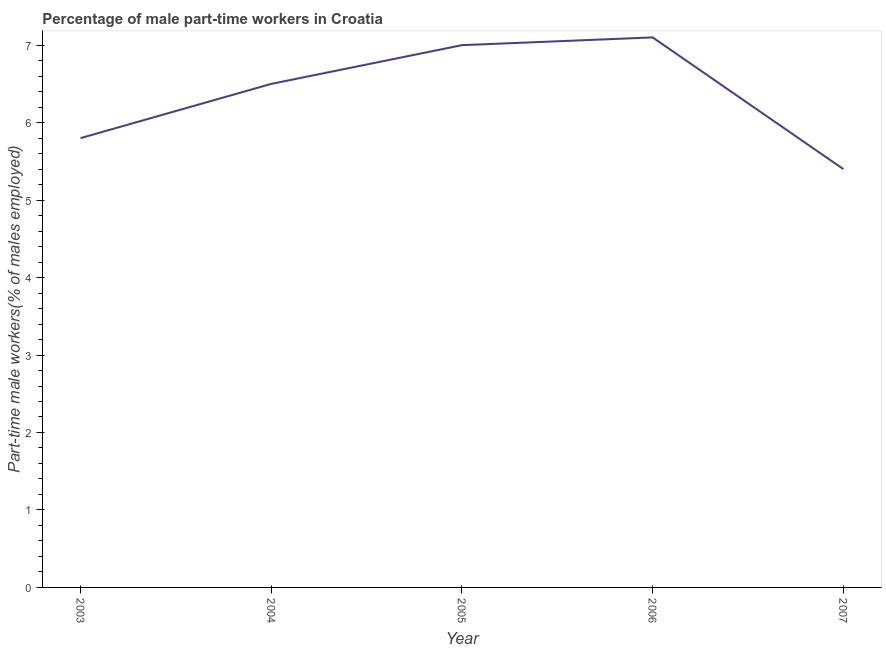What is the percentage of part-time male workers in 2003?
Your response must be concise. 5.8. Across all years, what is the maximum percentage of part-time male workers?
Keep it short and to the point. 7.1. Across all years, what is the minimum percentage of part-time male workers?
Your answer should be very brief. 5.4. In which year was the percentage of part-time male workers maximum?
Provide a short and direct response. 2006. In which year was the percentage of part-time male workers minimum?
Provide a succinct answer. 2007. What is the sum of the percentage of part-time male workers?
Offer a terse response. 31.8. What is the average percentage of part-time male workers per year?
Your response must be concise. 6.36. What is the ratio of the percentage of part-time male workers in 2005 to that in 2007?
Provide a short and direct response. 1.3. Is the percentage of part-time male workers in 2003 less than that in 2004?
Offer a terse response. Yes. Is the difference between the percentage of part-time male workers in 2006 and 2007 greater than the difference between any two years?
Your response must be concise. Yes. What is the difference between the highest and the second highest percentage of part-time male workers?
Make the answer very short. 0.1. Is the sum of the percentage of part-time male workers in 2006 and 2007 greater than the maximum percentage of part-time male workers across all years?
Give a very brief answer. Yes. What is the difference between the highest and the lowest percentage of part-time male workers?
Your response must be concise. 1.7. Does the percentage of part-time male workers monotonically increase over the years?
Ensure brevity in your answer.  No. How many lines are there?
Make the answer very short. 1. How many years are there in the graph?
Your answer should be very brief. 5. Are the values on the major ticks of Y-axis written in scientific E-notation?
Ensure brevity in your answer.  No. Does the graph contain grids?
Offer a terse response. No. What is the title of the graph?
Your answer should be very brief. Percentage of male part-time workers in Croatia. What is the label or title of the X-axis?
Your answer should be compact. Year. What is the label or title of the Y-axis?
Your response must be concise. Part-time male workers(% of males employed). What is the Part-time male workers(% of males employed) of 2003?
Keep it short and to the point. 5.8. What is the Part-time male workers(% of males employed) of 2004?
Keep it short and to the point. 6.5. What is the Part-time male workers(% of males employed) of 2006?
Your response must be concise. 7.1. What is the Part-time male workers(% of males employed) in 2007?
Provide a succinct answer. 5.4. What is the difference between the Part-time male workers(% of males employed) in 2003 and 2004?
Keep it short and to the point. -0.7. What is the difference between the Part-time male workers(% of males employed) in 2003 and 2006?
Your answer should be very brief. -1.3. What is the difference between the Part-time male workers(% of males employed) in 2004 and 2006?
Your response must be concise. -0.6. What is the difference between the Part-time male workers(% of males employed) in 2005 and 2007?
Provide a succinct answer. 1.6. What is the difference between the Part-time male workers(% of males employed) in 2006 and 2007?
Provide a succinct answer. 1.7. What is the ratio of the Part-time male workers(% of males employed) in 2003 to that in 2004?
Ensure brevity in your answer.  0.89. What is the ratio of the Part-time male workers(% of males employed) in 2003 to that in 2005?
Your answer should be very brief. 0.83. What is the ratio of the Part-time male workers(% of males employed) in 2003 to that in 2006?
Your answer should be very brief. 0.82. What is the ratio of the Part-time male workers(% of males employed) in 2003 to that in 2007?
Make the answer very short. 1.07. What is the ratio of the Part-time male workers(% of males employed) in 2004 to that in 2005?
Your answer should be compact. 0.93. What is the ratio of the Part-time male workers(% of males employed) in 2004 to that in 2006?
Offer a very short reply. 0.92. What is the ratio of the Part-time male workers(% of males employed) in 2004 to that in 2007?
Ensure brevity in your answer.  1.2. What is the ratio of the Part-time male workers(% of males employed) in 2005 to that in 2007?
Make the answer very short. 1.3. What is the ratio of the Part-time male workers(% of males employed) in 2006 to that in 2007?
Ensure brevity in your answer.  1.31. 